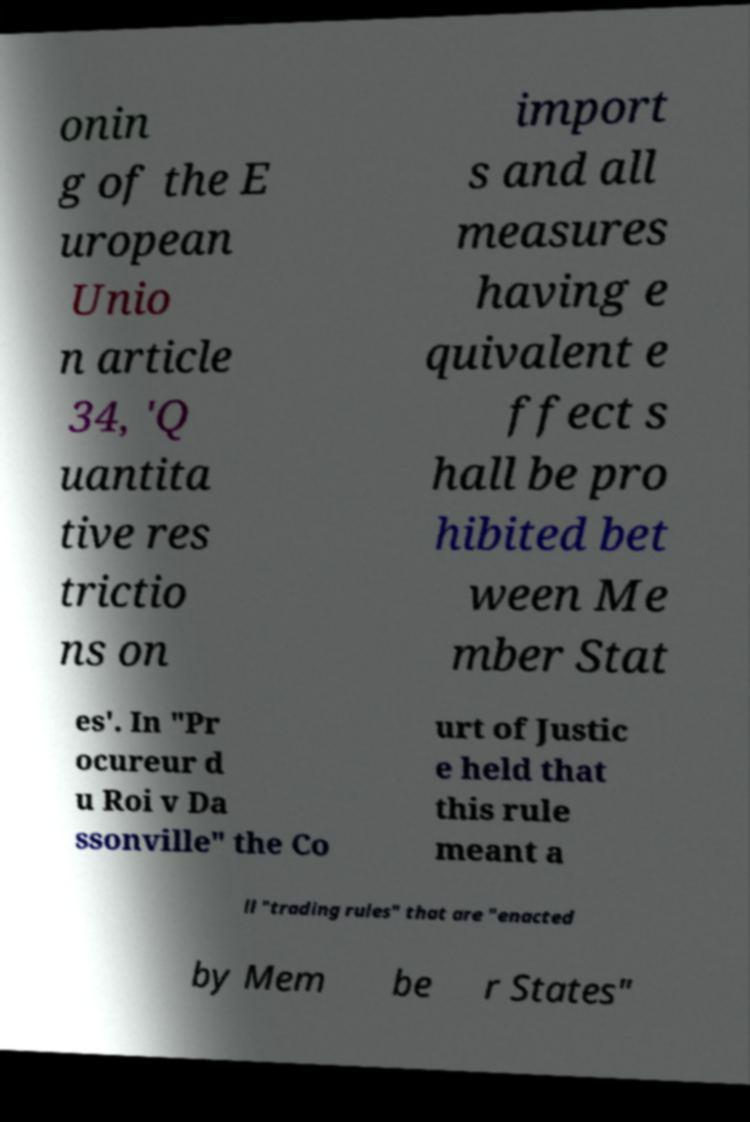Can you read and provide the text displayed in the image?This photo seems to have some interesting text. Can you extract and type it out for me? onin g of the E uropean Unio n article 34, 'Q uantita tive res trictio ns on import s and all measures having e quivalent e ffect s hall be pro hibited bet ween Me mber Stat es'. In "Pr ocureur d u Roi v Da ssonville" the Co urt of Justic e held that this rule meant a ll "trading rules" that are "enacted by Mem be r States" 